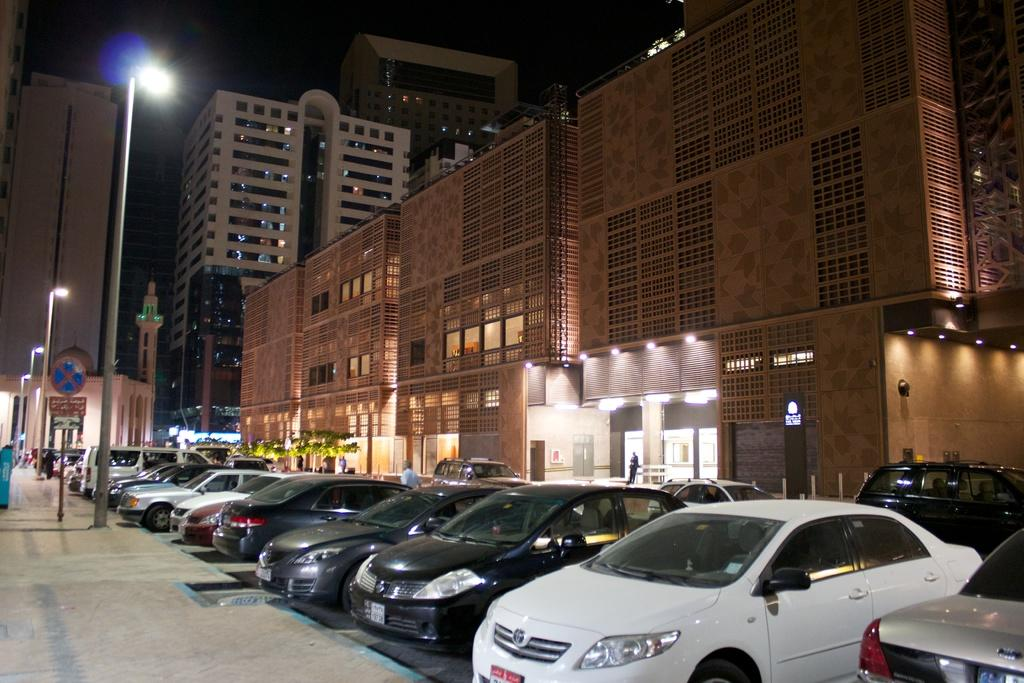What type of vehicles can be seen in the image? There are cars in the image. What is located on the left side of the image? There are lights on the left side of the image. What type of structures are on the right side of the image? There are buildings on the right side of the image. What type of discovery was made in the image? There is no mention of a discovery in the image; it features cars, lights, and buildings. How does the game being played in the image affect the balance of the structures? There is no game being played in the image, and therefore no impact on the balance of the structures. 